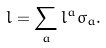<formula> <loc_0><loc_0><loc_500><loc_500>l = \sum _ { a } l ^ { a } \sigma _ { a } .</formula> 